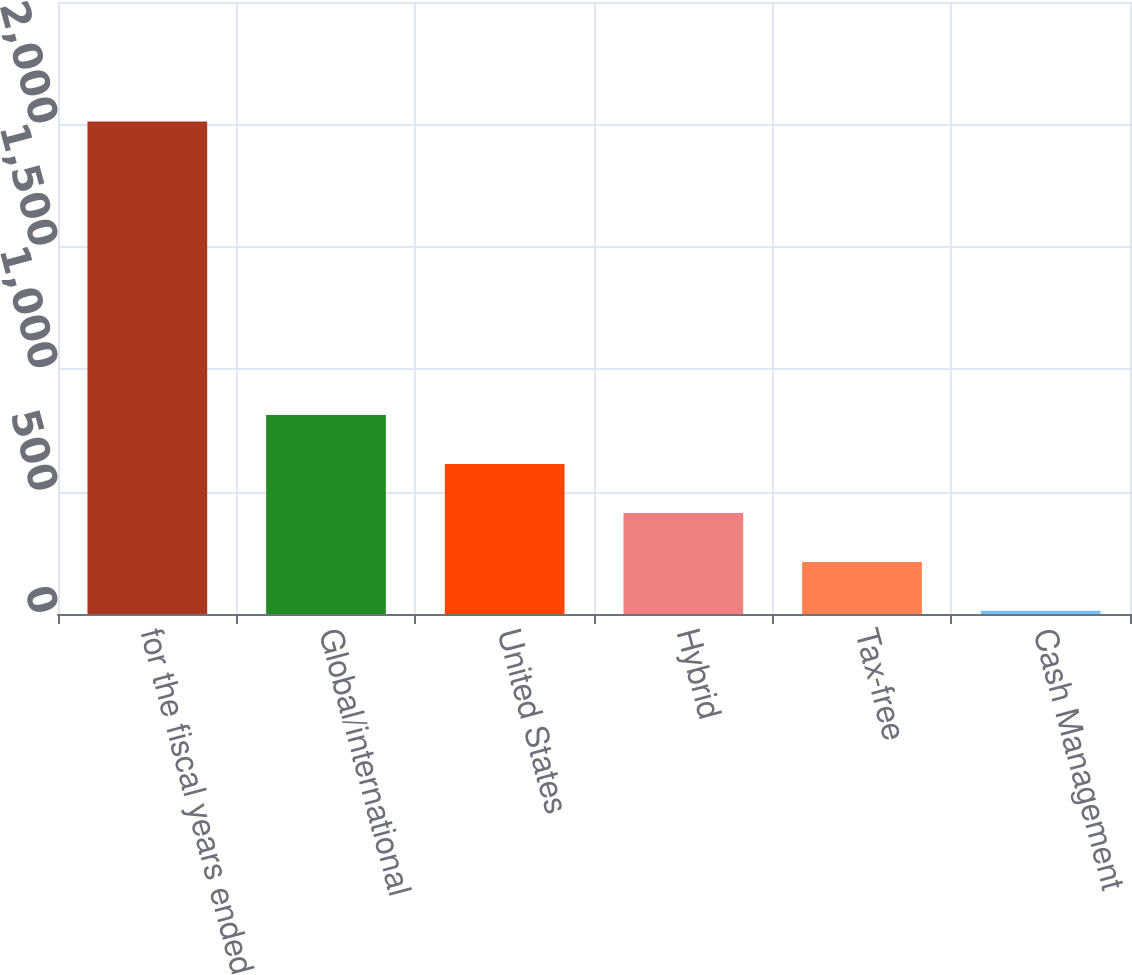<chart> <loc_0><loc_0><loc_500><loc_500><bar_chart><fcel>for the fiscal years ended<fcel>Global/international<fcel>United States<fcel>Hybrid<fcel>Tax-free<fcel>Cash Management<nl><fcel>2012<fcel>812.6<fcel>612.7<fcel>412.8<fcel>212.9<fcel>13<nl></chart> 